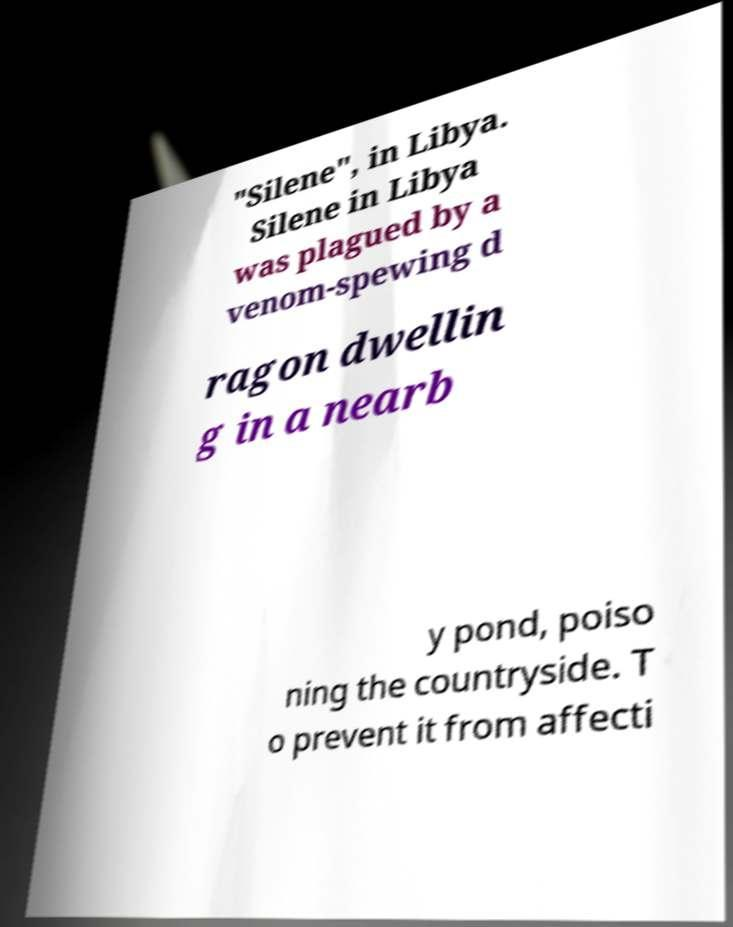Can you read and provide the text displayed in the image?This photo seems to have some interesting text. Can you extract and type it out for me? "Silene", in Libya. Silene in Libya was plagued by a venom-spewing d ragon dwellin g in a nearb y pond, poiso ning the countryside. T o prevent it from affecti 